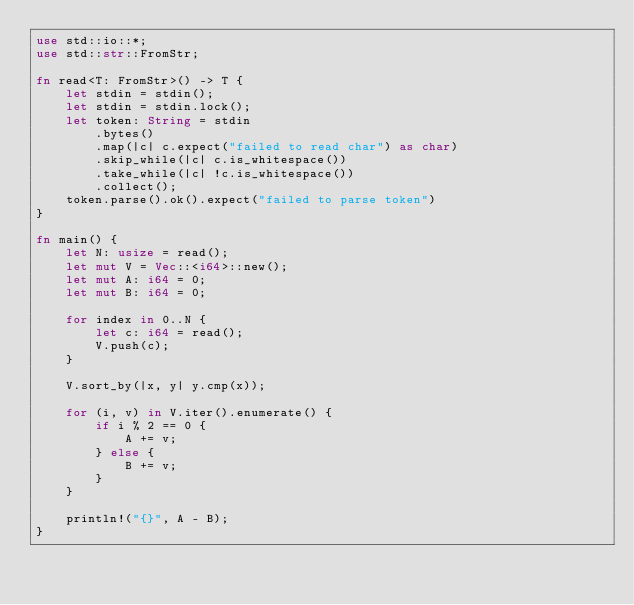<code> <loc_0><loc_0><loc_500><loc_500><_Rust_>use std::io::*;
use std::str::FromStr;

fn read<T: FromStr>() -> T {
    let stdin = stdin();
    let stdin = stdin.lock();
    let token: String = stdin
        .bytes()
        .map(|c| c.expect("failed to read char") as char) 
        .skip_while(|c| c.is_whitespace())
        .take_while(|c| !c.is_whitespace())
        .collect();
    token.parse().ok().expect("failed to parse token")
}

fn main() {
    let N: usize = read();
    let mut V = Vec::<i64>::new();
    let mut A: i64 = 0;
    let mut B: i64 = 0;

    for index in 0..N {
        let c: i64 = read();
        V.push(c);
    }

    V.sort_by(|x, y| y.cmp(x));

    for (i, v) in V.iter().enumerate() {
        if i % 2 == 0 {
            A += v;
        } else {
            B += v;
        }
    }

    println!("{}", A - B);
}
</code> 